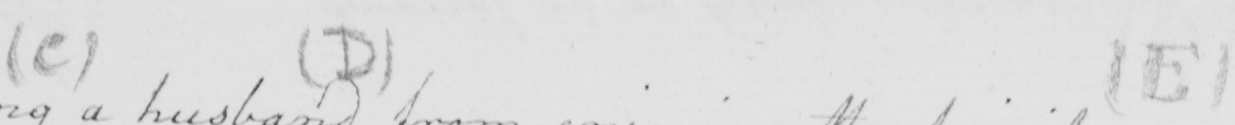What is written in this line of handwriting? ( C )   ( D )   ( E ) 